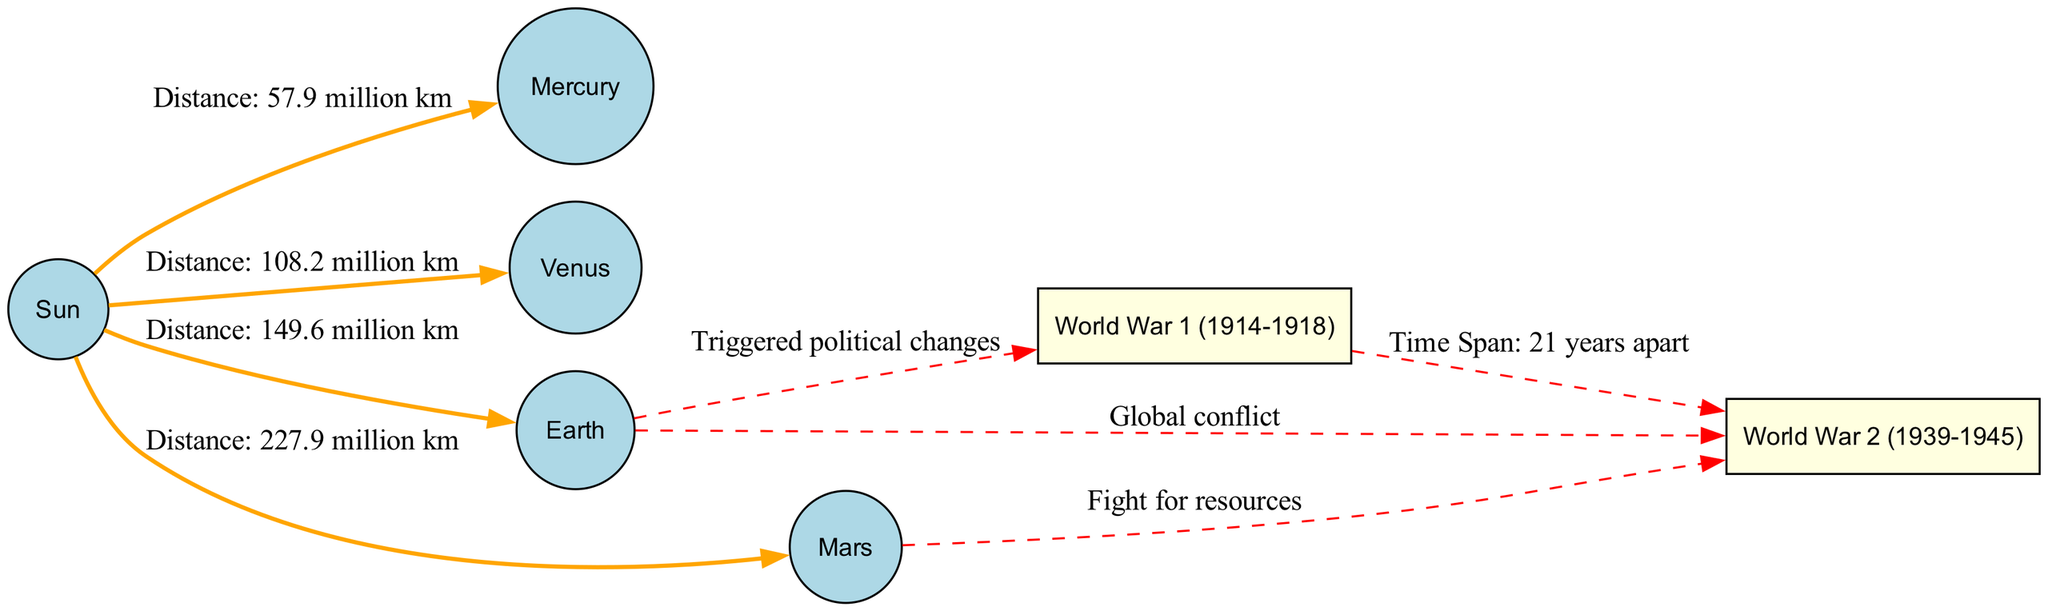What is the distance from the Sun to Venus? The diagram shows an edge from the Sun to Venus with the label indicating the distance. The label states "Distance: 108.2 million km," which provides the specific distance sought.
Answer: 108.2 million km How many years apart are World War 1 and World War 2? The diagram illustrates a relationship between the two wars with the label "Time Span: 21 years apart." This directly provides the information about the years separating the two conflicts.
Answer: 21 years Which planet is the farthest from the Sun in this diagram? The diagram features nodes for the planets along with the distances from the Sun. Among the listed distances, Mars has the maximum value of "Distance: 227.9 million km," indicating it's the farthest planet represented.
Answer: Mars What is the connection between Earth and World War 1? The diagram displays a connection from Earth to World War 1 labeled "Triggered political changes." This means Earth is associated with the political context leading to World War 1.
Answer: Triggered political changes Which two wars are represented in the diagram? The diagram includes nodes for World War 1 and World War 2, explicitly linked by an edge that shows their relation. The wars are clearly labeled in the diagram, which helps identify them.
Answer: World War 1, World War 2 What planet is associated with the fight for resources during World War 2? The diagram directly connects Mars to World War 2 with the label "Fight for resources." This indicates that Mars is related to the circumstances or context regarding resource conflicts in the war.
Answer: Mars What color represents the nodes for planets? The diagram specifies that the planet nodes are filled with the color "lightblue." This is an essential characteristic of how planets are visually depicted in the diagram to differentiate them from other entities.
Answer: Lightblue How is the relationship between Earth and World War 2 described? The connection is shown in the diagram with the label "Global conflict," which succinctly summarizes the overarching thematic relationship between the Earth and the onset of World War 2.
Answer: Global conflict 